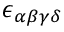Convert formula to latex. <formula><loc_0><loc_0><loc_500><loc_500>\epsilon _ { \alpha \beta \gamma \delta }</formula> 